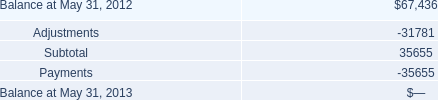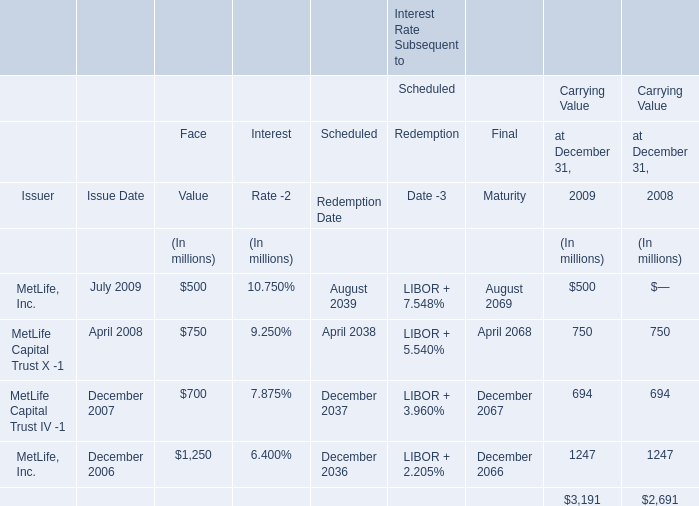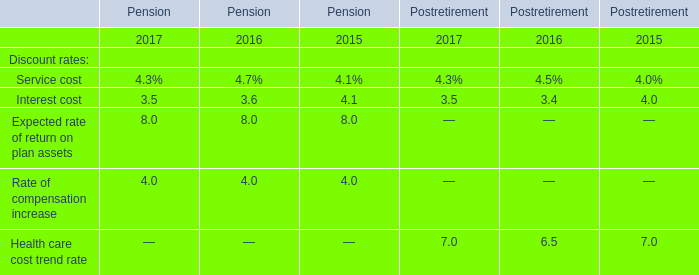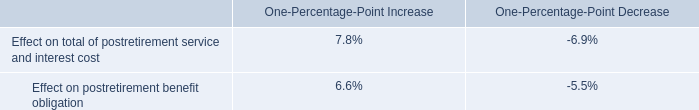What was the total amount of the MetLife Capital Trust IV -1 of Carrying Value in the years where MetLife Capital Trust X -1 greater than 700? (in million) 
Computations: (694 + 694)
Answer: 1388.0. 